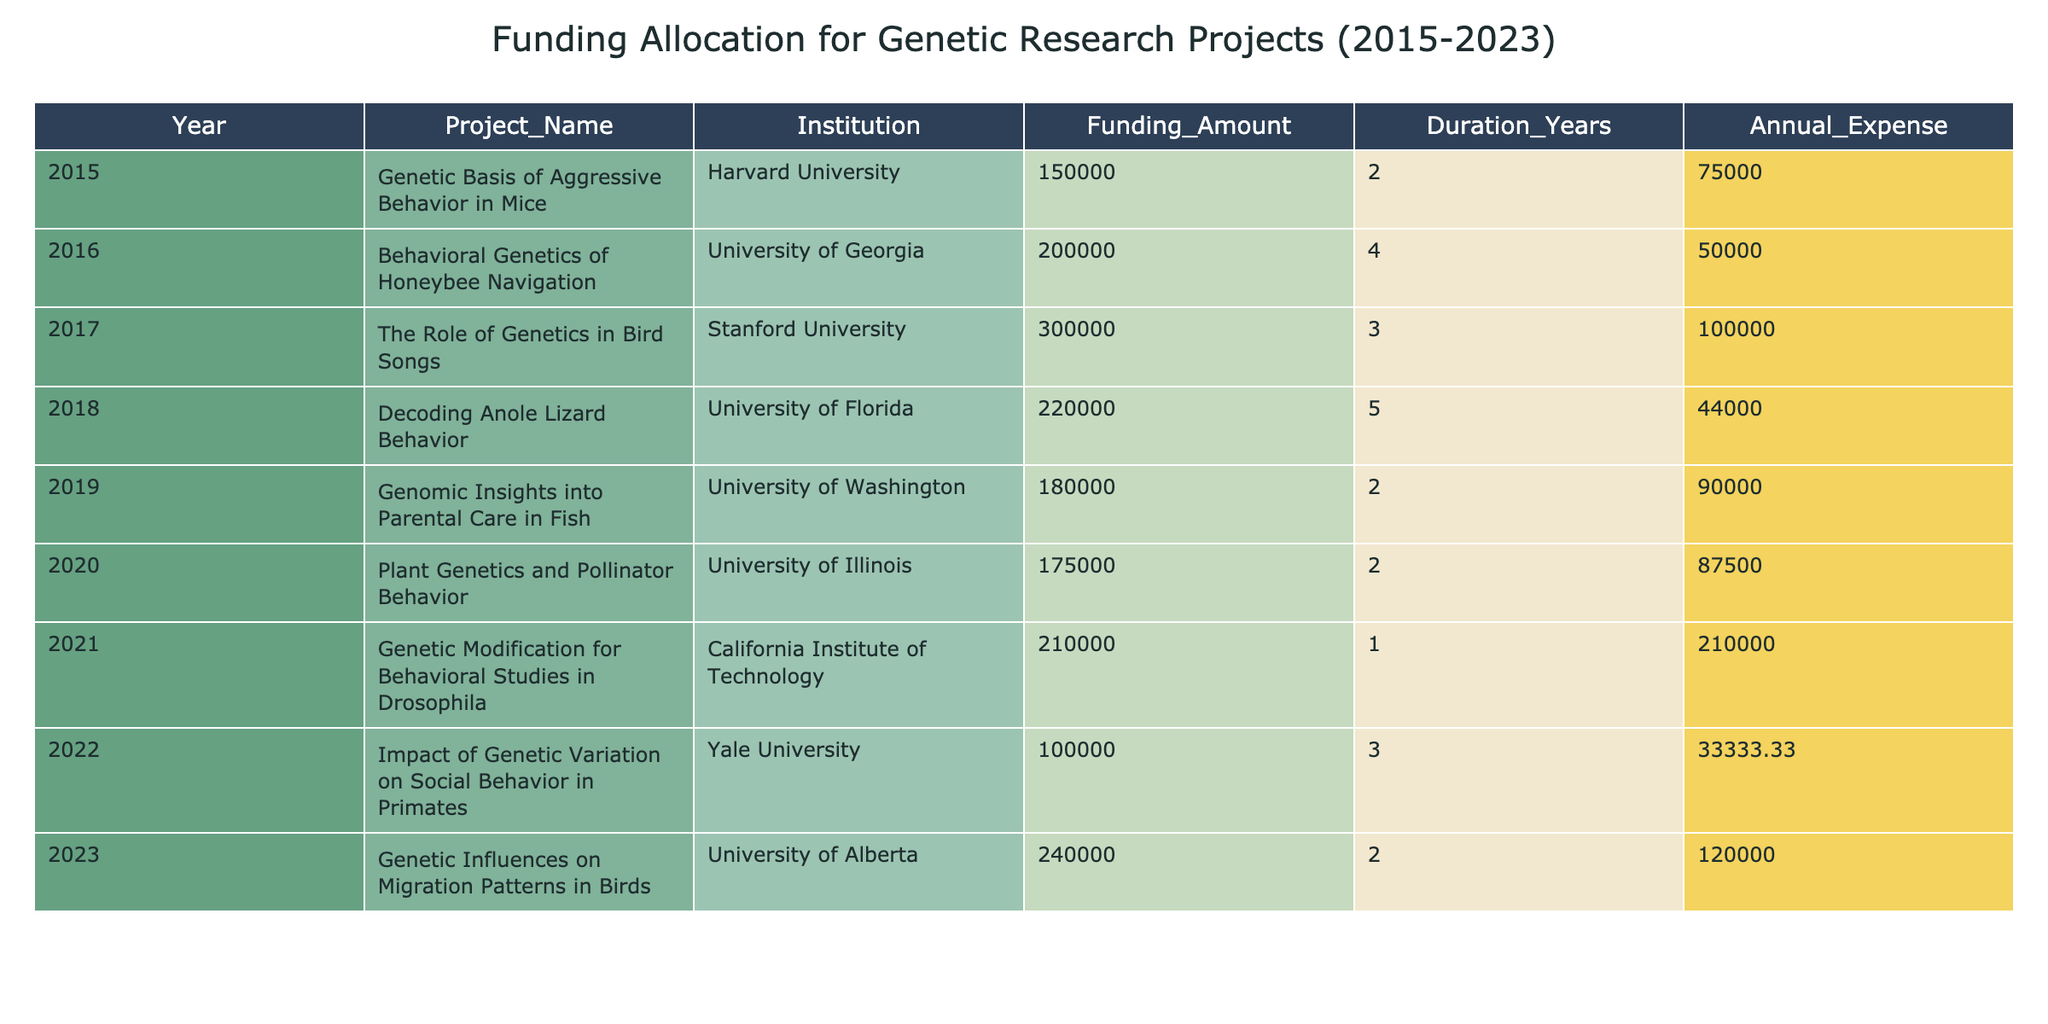What is the total funding allocated for projects in 2015? The table shows that the funding amount for the project in 2015, "Genetic Basis of Aggressive Behavior in Mice," is 150000. Since there is only one project in that year, the total funding is the same as the funding amount.
Answer: 150000 Which project received the highest annual expense? By comparing the annual expenses for each project, "Genetic Modification for Behavioral Studies in Drosophila" has an annual expense of 210000, which is the highest compared to others.
Answer: 210000 What is the average funding amount across all projects from 2015 to 2023? The sum of the funding amounts for the projects (150000 + 200000 + 300000 + 220000 + 180000 + 175000 + 210000 + 100000 + 240000) equals 1575000. There are 9 projects so the average is 1575000 / 9 = 175000.
Answer: 175000 Did any project last more than three years? Looking at the Duration Years column, "Behavioral Genetics of Honeybee Navigation," "Decoding Anole Lizard Behavior," and "Impact of Genetic Variation on Social Behavior in Primates" last longer than three years (4, 5, and 3 years respectively). Therefore, there are projects that last more than three years.
Answer: Yes What is the funding gap between the project with the highest funding and the one with the lowest? The project with the highest funding is "The Role of Genetics in Bird Songs" at 300000 and the one with the lowest funding is "Impact of Genetic Variation on Social Behavior in Primates" at 100000. The funding gap is 300000 - 100000 = 200000.
Answer: 200000 Which institution received the least funding in 2020? In 2020, the project is "Plant Genetics and Pollinator Behavior" funded with 175000. Since we are only considering one project that year, this represents the least funding.
Answer: 175000 What percentage of the total funding went to the project on bird songs? The total funding is 1575000 and the funding for "The Role of Genetics in Bird Songs" is 300000. Therefore, the percentage is (300000 / 1575000) * 100 = 19.05%.
Answer: 19.05% Which year had the second highest amount of funding? Listing the funding amounts by year: 2015 (150000), 2016 (200000), 2017 (300000), 2018 (220000), 2019 (180000), 2020 (175000), 2021 (210000), 2022 (100000), 2023 (240000). The highest is 300000 in 2017, and the second highest is 240000 in 2023.
Answer: 2023 